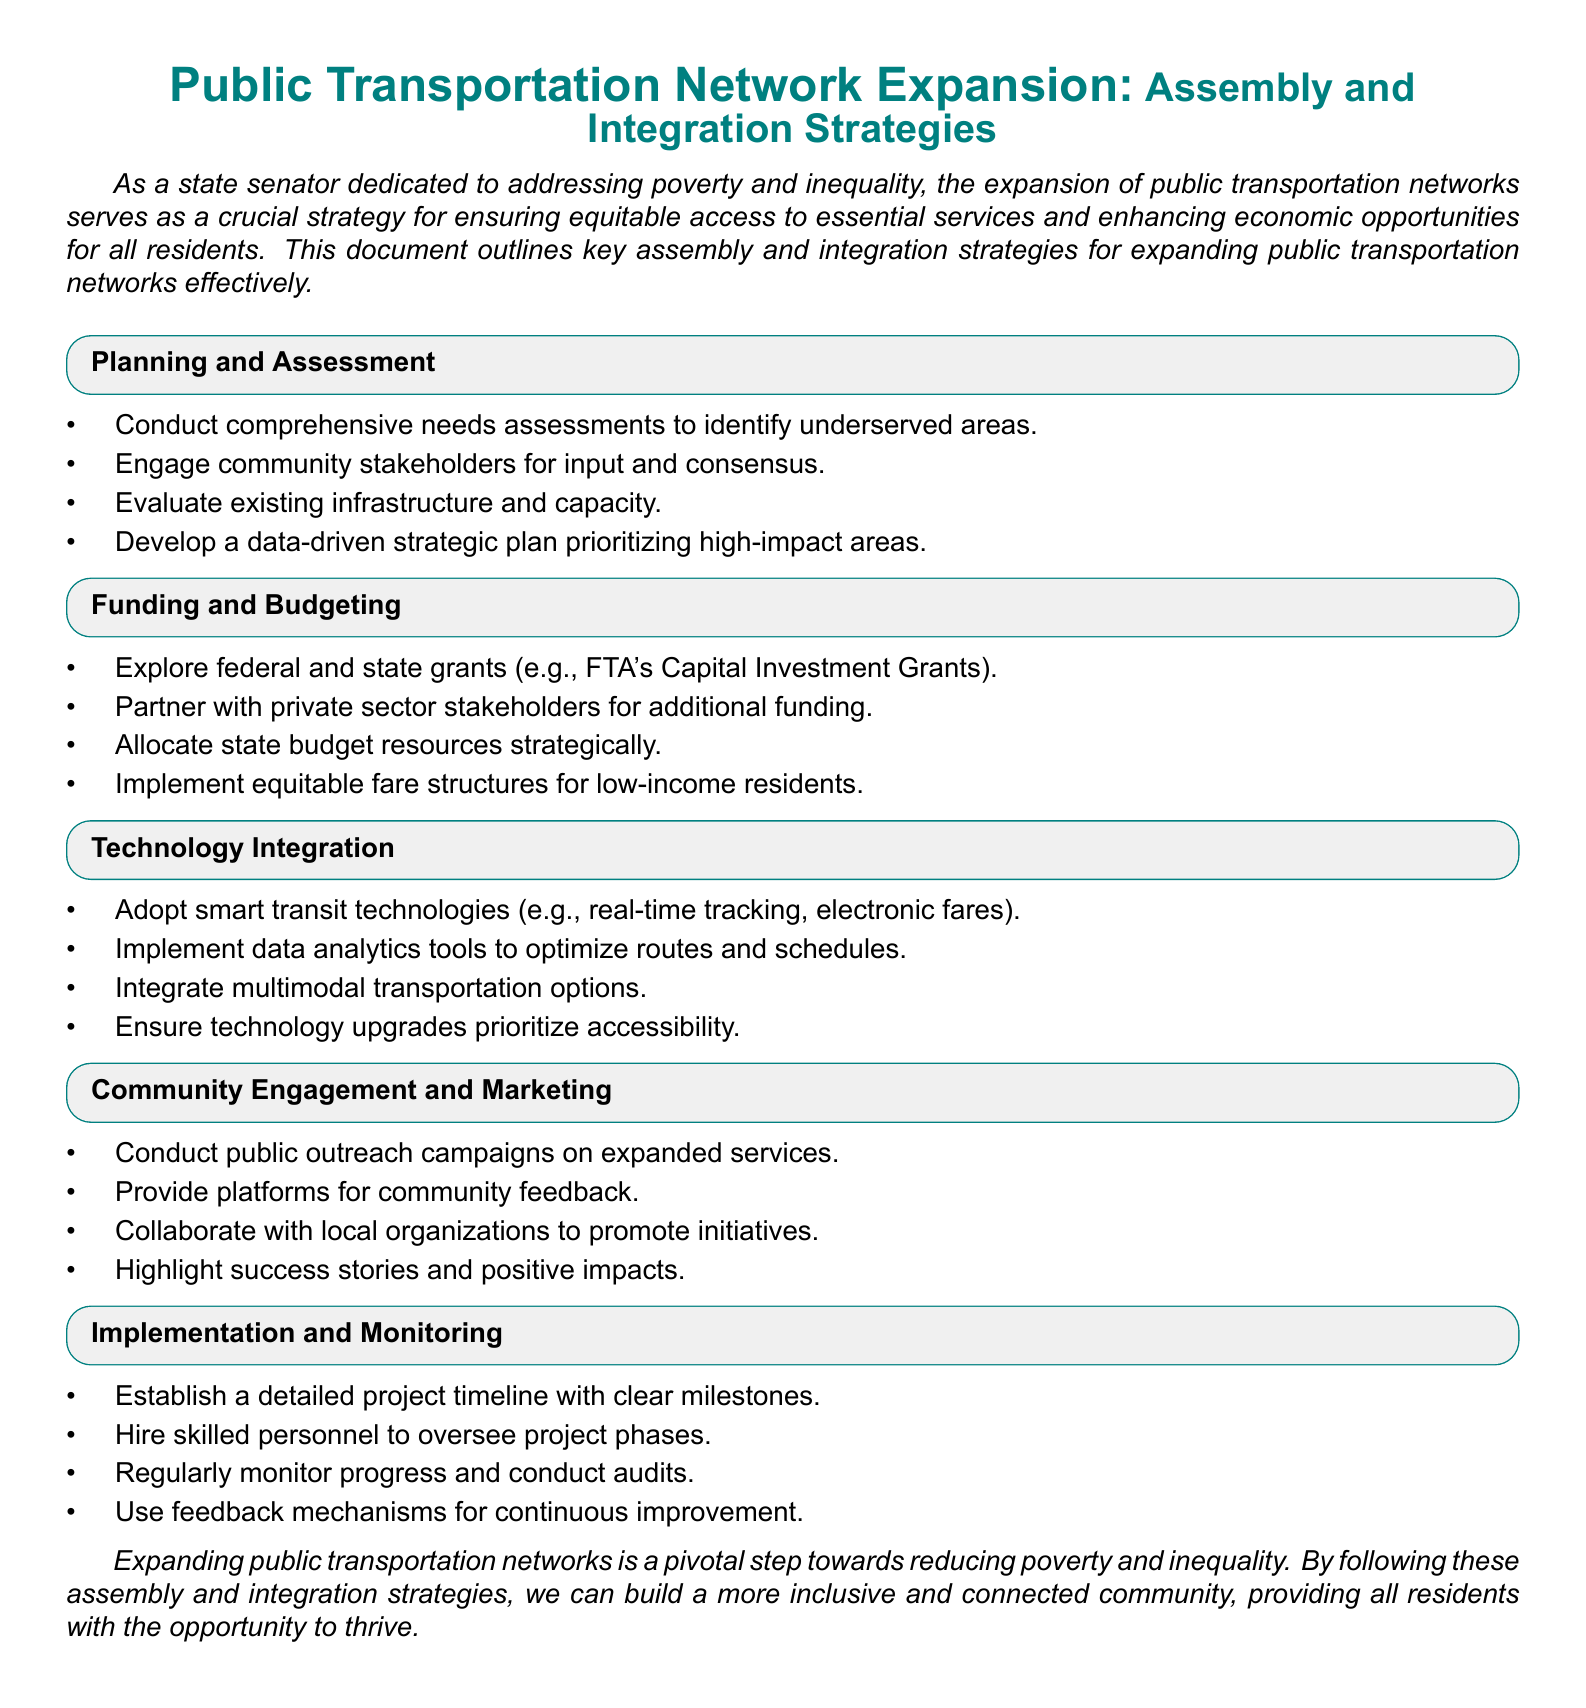What is the title of the document? The title of the document is mentioned at the beginning, which summarizes the focus on public transportation network expansion.
Answer: Public Transportation Network Expansion: Assembly and Integration Strategies What are the four main sections of the document? The main sections include Planning and Assessment, Funding and Budgeting, Technology Integration, Community Engagement and Marketing, and Implementation and Monitoring.
Answer: Planning and Assessment, Funding and Budgeting, Technology Integration, Community Engagement and Marketing, Implementation and Monitoring What types of stakeholders should be engaged according to the document? The document recommends engaging community stakeholders for input and consensus during the planning phase.
Answer: Community stakeholders Which federal grants are mentioned as funding sources? The federal grants referenced are FTA's Capital Investment Grants.
Answer: FTA's Capital Investment Grants What is one of the smart transit technologies proposed? The document mentions real-time tracking as an example of smart transit technology that should be adopted.
Answer: Real-time tracking How should progress be monitored after the project begins? The document states that regular monitoring of progress and conducting audits are necessary to ensure project efficiency.
Answer: Regularly monitor progress and conduct audits What is one strategy to ensure fare equity? The document suggests implementing equitable fare structures for low-income residents as a strategy to ensure fare equity.
Answer: Equitable fare structures for low-income residents What should be included in the project timeline? A detailed project timeline with clear milestones should be established according to the document.
Answer: Detailed project timeline with clear milestones Which method is recommended for collecting community feedback? The document recommends providing platforms for community feedback as a method for engagement.
Answer: Platforms for community feedback 